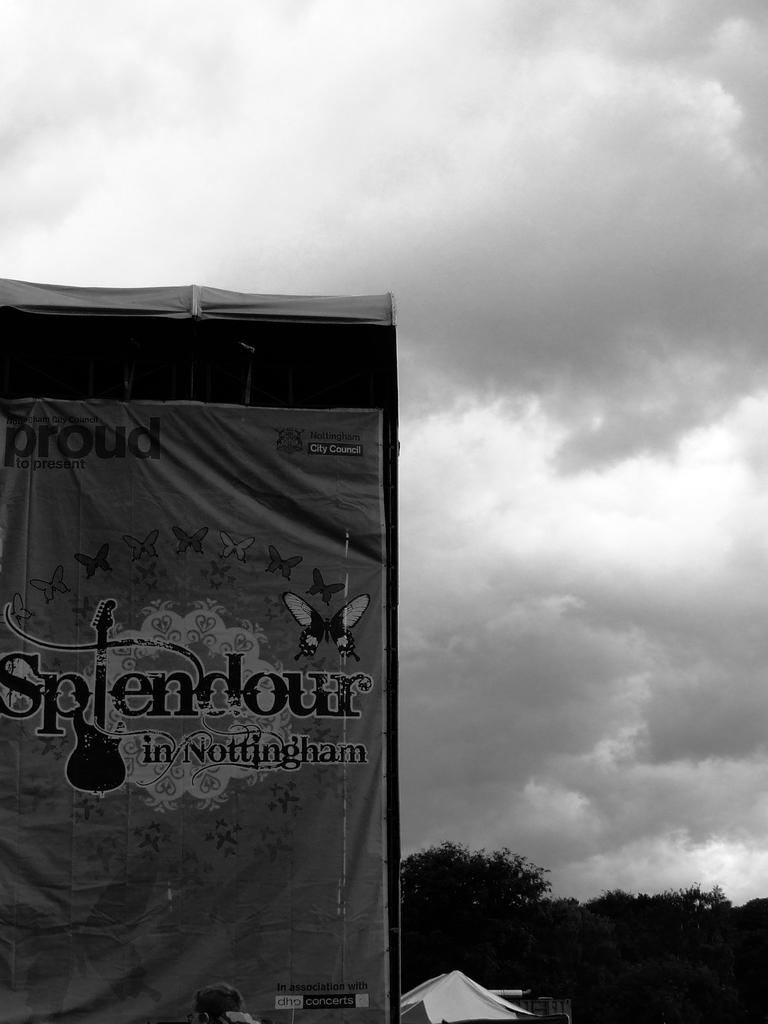What is located on the left side of the image? There is a banner in the left side of the image. What can be seen in the background of the image? There are trees and buildings in the background of the image. What is the condition of the sky in the image? The sky is cloudy in the image. What type of prose can be heard being read from the banner in the image? There is no prose being read from the banner in the image, as it is a visual object and not a source of sound. 